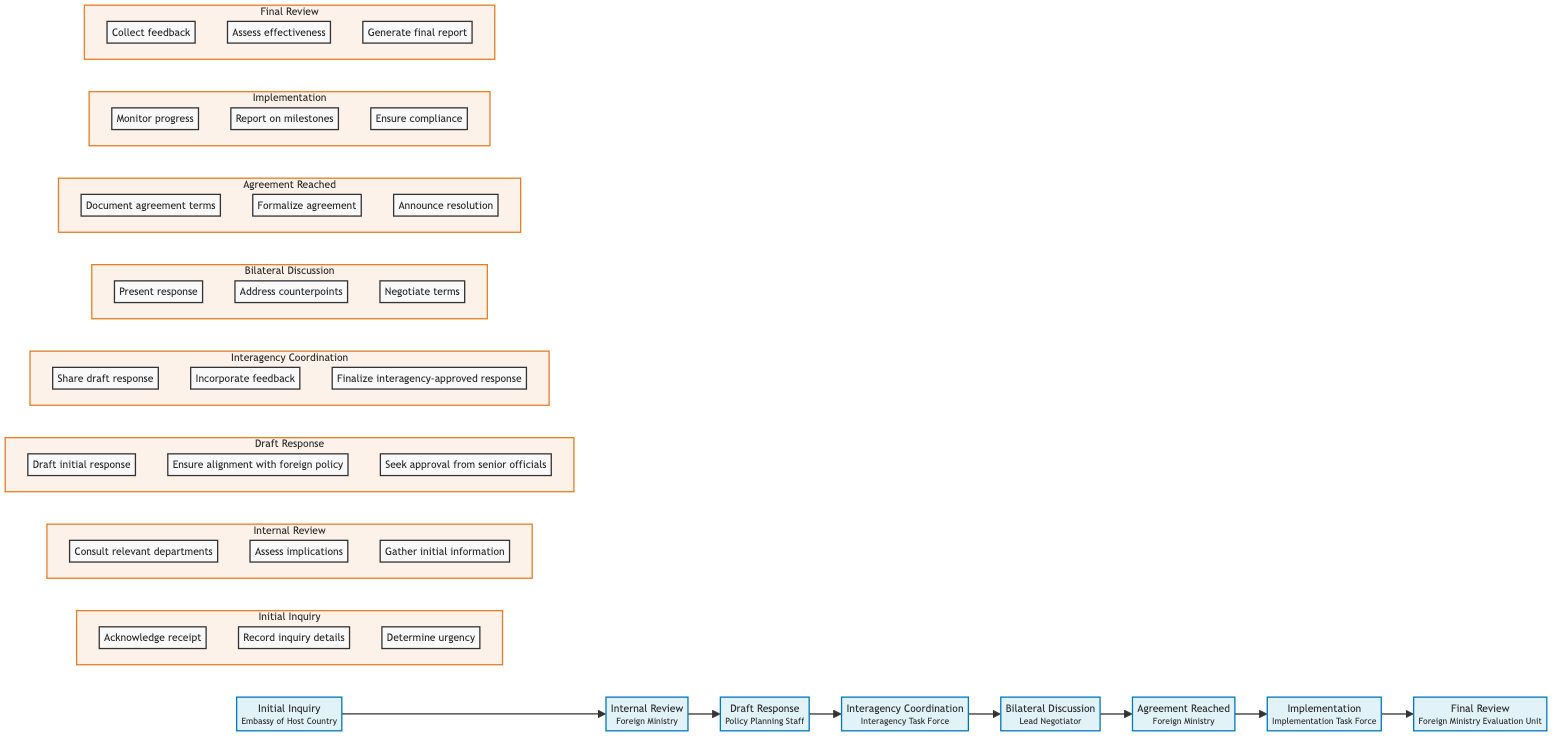What is the first stage in the diplomatic communication pathway? The first stage is identified as "Initial Inquiry," which is clearly marked as the starting point of the horizontal flowchart.
Answer: Initial Inquiry How many stages are included in the diagram? By counting each distinct box in the horizontal flowchart, we find there are eight stages total: Initial Inquiry, Internal Review, Draft Response, Interagency Coordination, Bilateral Discussion, Agreement Reached, Implementation, and Final Review.
Answer: Eight Who is responsible for the "Draft Response" stage? The "Draft Response" stage is assigned to the "Policy Planning Staff," which is mentioned in the corresponding box of the flowchart.
Answer: Policy Planning Staff What action is taken in the "Bilateral Discussion" stage? During the "Bilateral Discussion" stage, the action taken is to "Present response," explicitly listed within the actions connected to that stage in the flowchart.
Answer: Present response Which stage directly precedes the "Agreement Reached" stage? The stage that comes immediately before "Agreement Reached" is "Bilateral Discussion," as indicated by the directional flow in the horizontal diagram showing the sequence of stages.
Answer: Bilateral Discussion How many actions are listed under the "Implementation" stage? In the "Implementation" stage, there are three actions listed: "Monitor progress," "Report on milestones," and "Ensure compliance," which can be counted directly from the diagram.
Answer: Three What is the primary responsibility of the "Implementation Task Force"? The primary responsibility of the "Implementation Task Force" is stated in the diagram as "Carry out agreed-upon actions," which summarizes their main function in this stage.
Answer: Carry out agreed-upon actions How many government entities are involved in this workflow? By looking at each stage and noting the responsible entities, we can see that there are five distinct entities involved: Embassy of Host Country, Foreign Ministry, Policy Planning Staff, Interagency Task Force, and Lead Negotiator.
Answer: Five 